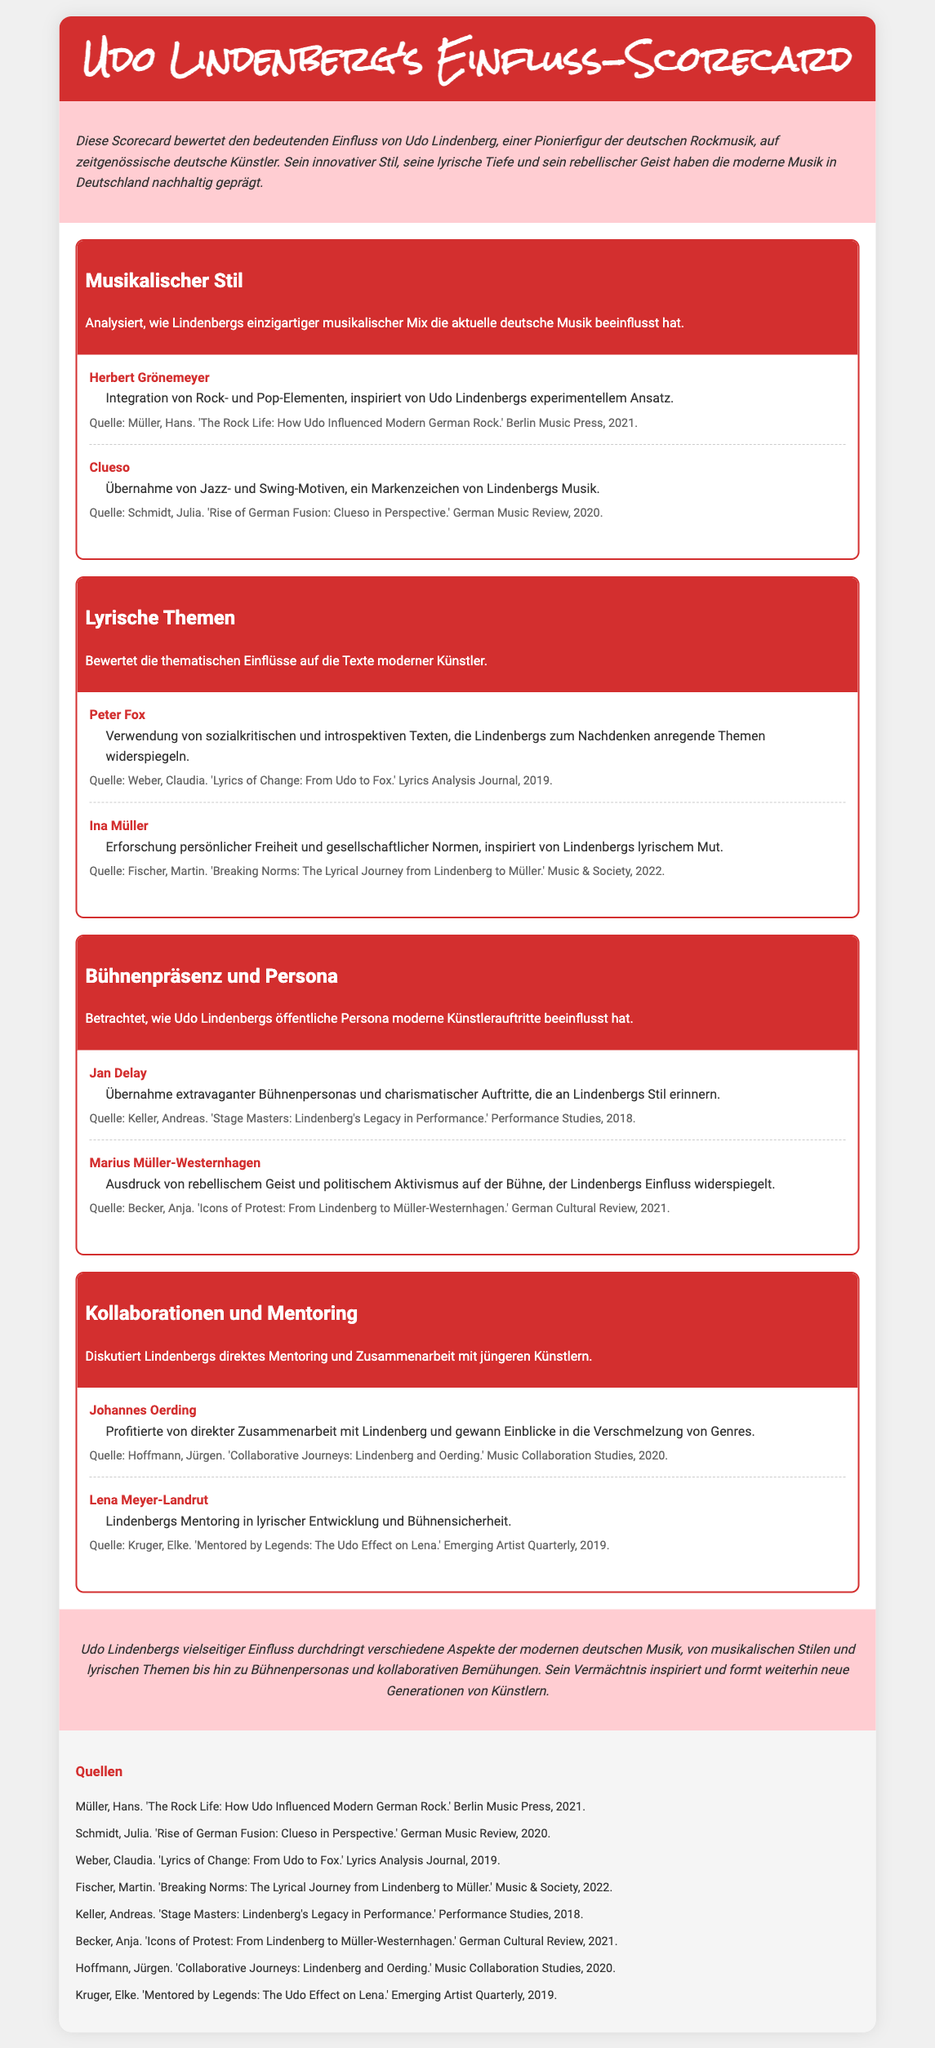What is the title of the scorecard? The title is stated in the header of the document.
Answer: Udo Lindenberg's Einfluss-Scorecard Who is mentioned as integrating Rock- und Pop-Elemente? This artist is identified in the 'Musikalischer Stil' section.
Answer: Herbert Grönemeyer What lyrical theme does Peter Fox reflect? This is mentioned in the 'Lyrische Themen' section.
Answer: sozialkritischen und introspektiven Texten Which artist is noted for extravagant Bühnenpersonas? This detail can be found in the 'Bühnenpräsenz und Persona' section.
Answer: Jan Delay What was the focus of Lindenberg's mentoring with Lena Meyer-Landrut? This is discussed in the 'Kollaborationen und Mentoring' section.
Answer: lyrischer Entwicklung und Bühnensicherheit How many categories are evaluated in the scorecard? The number of categories is counted in the document structure.
Answer: Four 